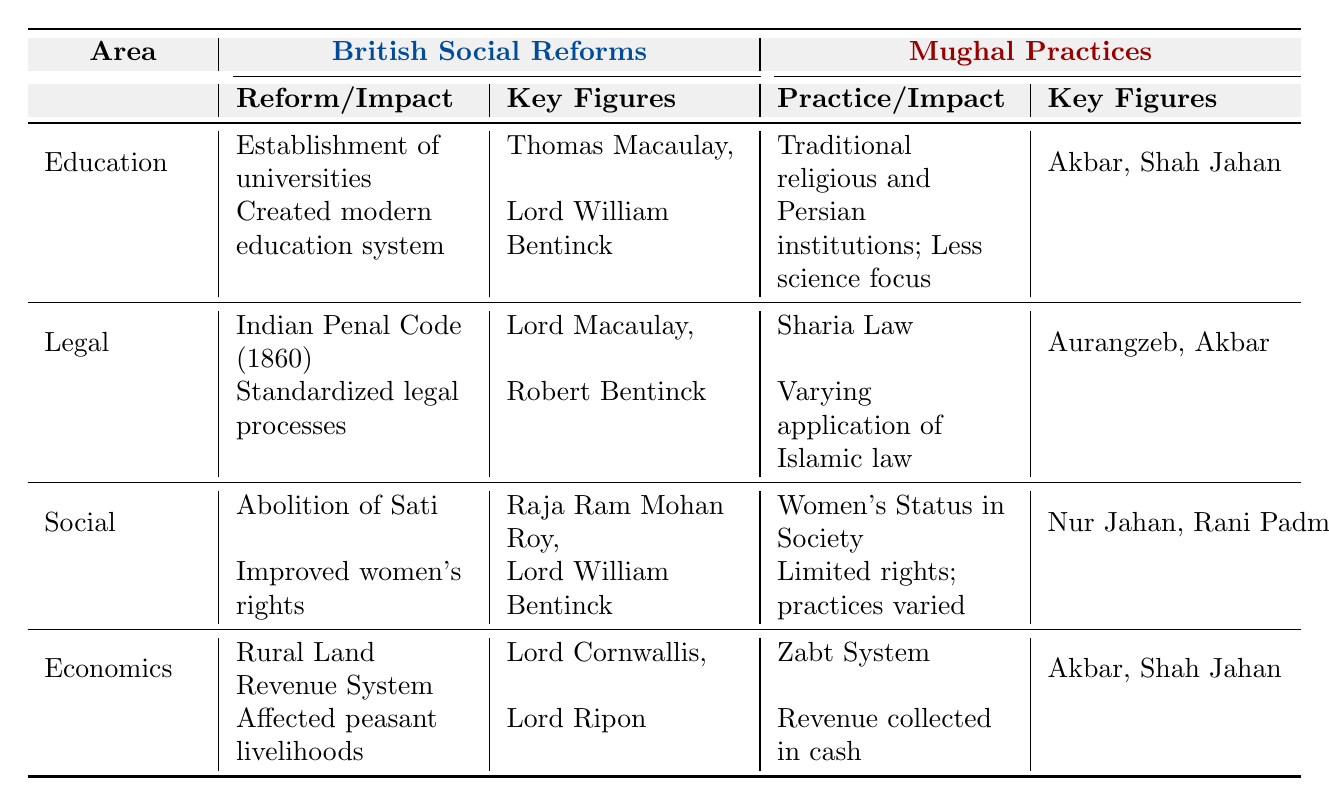What was the impact of the British reform regarding education? The British established universities, which created a modern education system emphasizing Western knowledge. This is indicated in the "Impact" column under the "Education" section in the British Social Reforms.
Answer: Created a modern education system emphasizing Western knowledge Who were the key figures involved in the abolition of Sati? The key figures listed in the table for the abolition of Sati reform under British Social Reforms are Raja Ram Mohan Roy and Lord William Bentinck.
Answer: Raja Ram Mohan Roy, Lord William Bentinck What was the Mughal practice concerning women's status in society? The Mughal practice indicated a significant cultural role for women but limited rights, with variations in practices. This is noted in the "Impact" column under the "Social" section in the Mughal Practices.
Answer: Women had significant cultural roles but limited rights; practices varied Which social reform aimed to improve women's rights, and what impact did it have? The abolition of Sati aimed to improve women’s rights by reducing the practice of widow self-immolation. This is detailed in the British Social Reforms section under "Social."
Answer: Improved women's rights by reducing self-immolation Is the Indian Penal Code associated with British or Mughal legal practices? The Indian Penal Code is a reform introduced by the British, as indicated in the "Legal" section of British Social Reforms.
Answer: British Compare the education focus of British reforms and Mughal practices. British reforms established universities that emphasized Western knowledge, while Mughal practices focused on religious education with less emphasis on science, as shown in the respective sections.
Answer: British focused on Western knowledge; Mughal focused on religious education What was the land revenue system used by the Mughals? The Mughal land revenue system was called the Zabt system, where revenue was collected in cash, as noted in the "Economics" section of Mughal Practices.
Answer: Zabt System How did the key figures in British legal reforms differ from those in Mughal legal practices? The key figures in British legal reforms included Lord Macaulay and Robert Bentinck, while Mughal practices involved Aurangzeb and Akbar. This distinction can be found in the corresponding sections of the table.
Answer: They differ; British: Lord Macaulay, Robert Bentinck; Mughal: Aurangzeb, Akbar What was a common theme between British and Mughal social impacts on women? Both systems had their limitations on women's rights; the British reform aimed to improve women's rights through the abolition of Sati, whereas the Mughal practices granted limited rights despite cultural roles. This can be deduced from comparing the "Social" sections of both.
Answer: Both had limitations on women’s rights Which economic reform implemented by the British affected peasant livelihoods? The Rural Land Revenue System introduced by the British impacted peasant livelihoods as mentioned in the "Economics" section under British Social Reforms.
Answer: Rural Land Revenue System affected livelihoods 